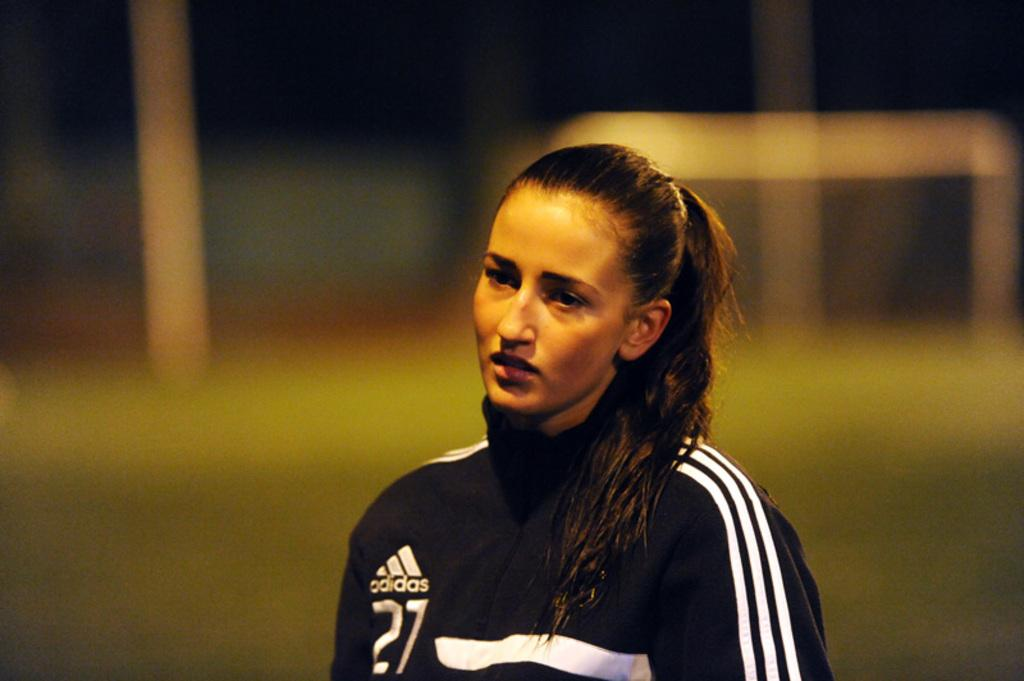<image>
Give a short and clear explanation of the subsequent image. A girl with a ponytail is wearing a black and white Adidas jacket with the number 27 on it. 